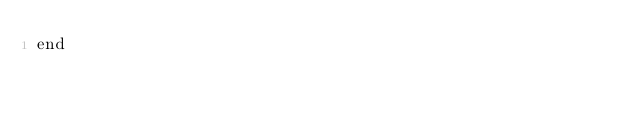<code> <loc_0><loc_0><loc_500><loc_500><_Ruby_>end
</code> 